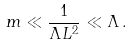Convert formula to latex. <formula><loc_0><loc_0><loc_500><loc_500>m \ll \frac { 1 } { \Lambda L ^ { 2 } } \ll \Lambda \, .</formula> 